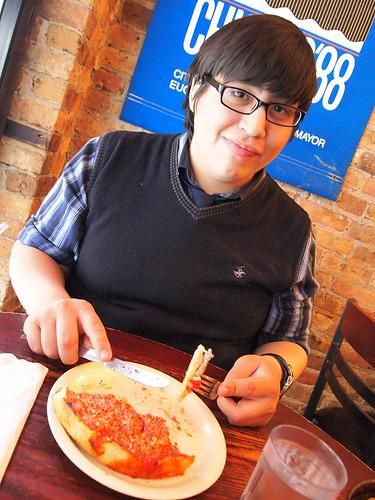Question: what is the color of the glass?
Choices:
A. Green.
B. Clear.
C. Blue.
D. Red.
Answer with the letter. Answer: B 